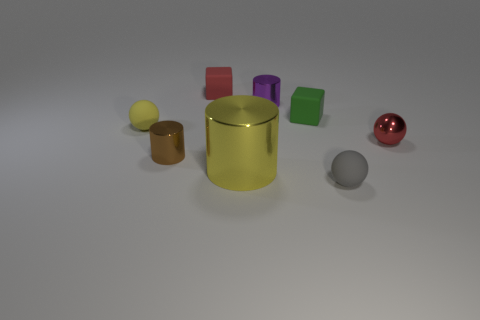Subtract all small cylinders. How many cylinders are left? 1 Add 1 small red metallic spheres. How many objects exist? 9 Subtract all brown cylinders. How many cylinders are left? 2 Subtract 2 cylinders. How many cylinders are left? 1 Subtract all cubes. How many objects are left? 6 Subtract all yellow cubes. Subtract all red spheres. How many cubes are left? 2 Subtract all cyan cylinders. How many green cubes are left? 1 Subtract all large cylinders. Subtract all gray matte balls. How many objects are left? 6 Add 3 large metal cylinders. How many large metal cylinders are left? 4 Add 1 purple things. How many purple things exist? 2 